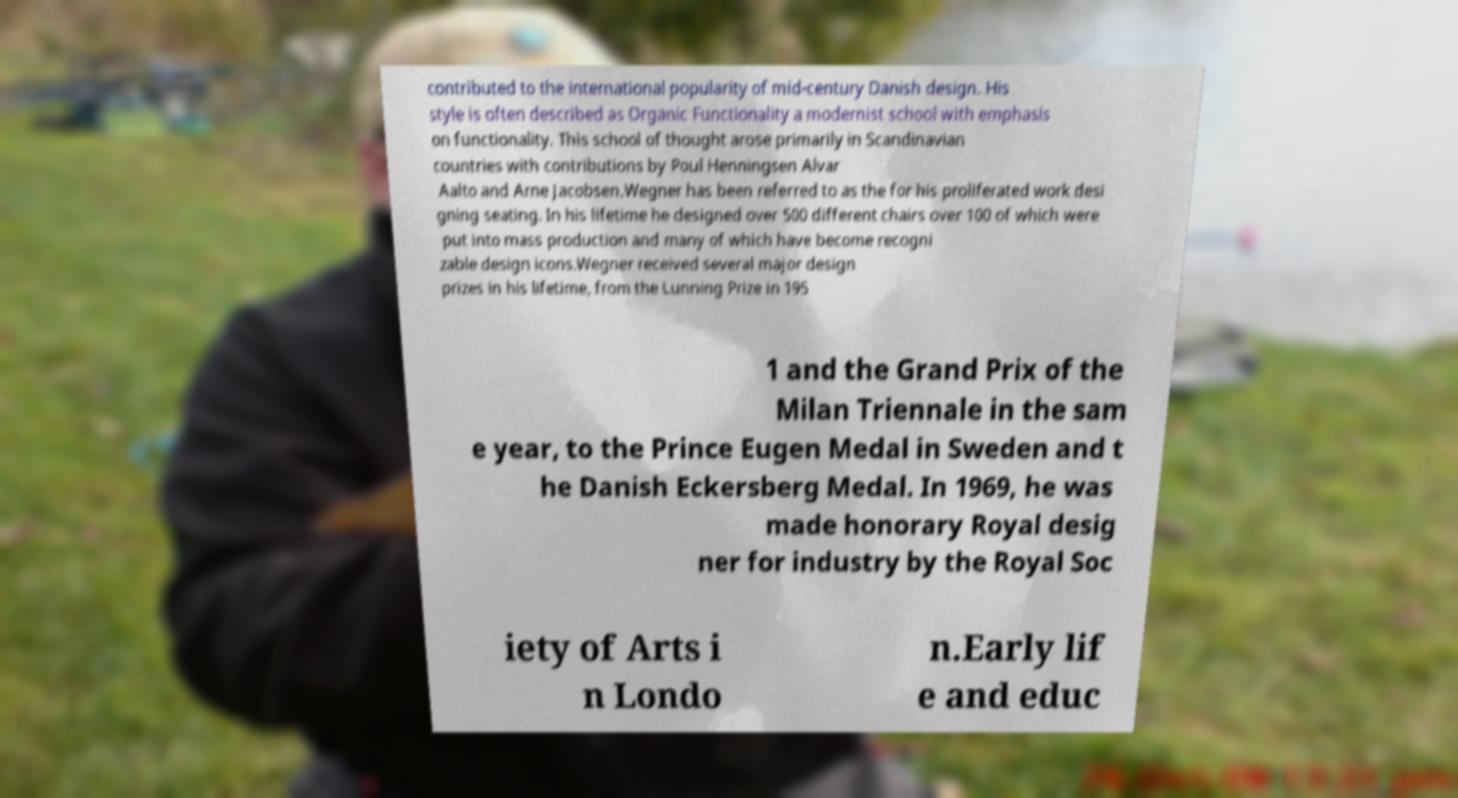Please read and relay the text visible in this image. What does it say? contributed to the international popularity of mid-century Danish design. His style is often described as Organic Functionality a modernist school with emphasis on functionality. This school of thought arose primarily in Scandinavian countries with contributions by Poul Henningsen Alvar Aalto and Arne Jacobsen.Wegner has been referred to as the for his proliferated work desi gning seating. In his lifetime he designed over 500 different chairs over 100 of which were put into mass production and many of which have become recogni zable design icons.Wegner received several major design prizes in his lifetime, from the Lunning Prize in 195 1 and the Grand Prix of the Milan Triennale in the sam e year, to the Prince Eugen Medal in Sweden and t he Danish Eckersberg Medal. In 1969, he was made honorary Royal desig ner for industry by the Royal Soc iety of Arts i n Londo n.Early lif e and educ 